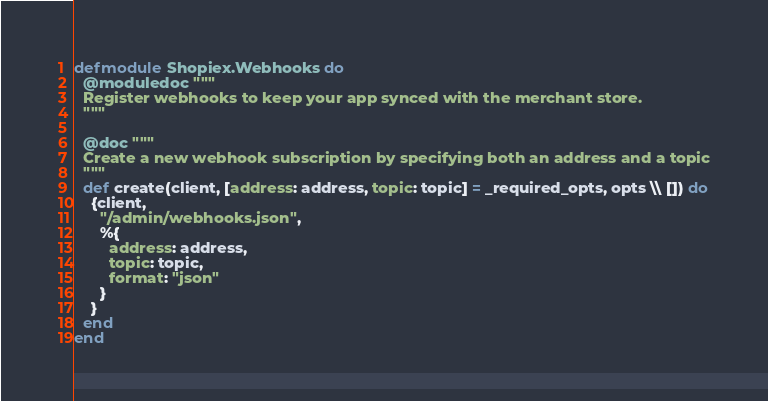Convert code to text. <code><loc_0><loc_0><loc_500><loc_500><_Elixir_>defmodule Shopiex.Webhooks do
  @moduledoc """
  Register webhooks to keep your app synced with the merchant store.
  """

  @doc """
  Create a new webhook subscription by specifying both an address and a topic
  """
  def create(client, [address: address, topic: topic] = _required_opts, opts \\ []) do
    {client,
      "/admin/webhooks.json",
      %{
        address: address,
        topic: topic,
        format: "json"
      }
    }
  end
end
</code> 